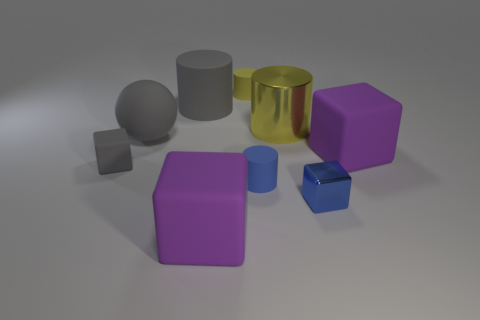What size is the matte sphere that is the same color as the big matte cylinder?
Keep it short and to the point. Large. There is a cylinder that is the same color as the tiny metal thing; what is its material?
Make the answer very short. Rubber. Is there a gray cube that has the same size as the ball?
Your response must be concise. No. Are there the same number of small cubes that are right of the large metal object and small gray blocks right of the big gray sphere?
Provide a succinct answer. No. Are there more big gray cylinders than metallic objects?
Your response must be concise. No. How many matte objects are tiny red cylinders or cylinders?
Ensure brevity in your answer.  3. What number of shiny blocks are the same color as the large metallic object?
Keep it short and to the point. 0. There is a big cube in front of the gray thing in front of the big cube that is on the right side of the blue cylinder; what is it made of?
Your answer should be very brief. Rubber. What is the color of the tiny block to the left of the big rubber thing that is left of the gray cylinder?
Your answer should be very brief. Gray. How many large objects are gray rubber balls or rubber cubes?
Make the answer very short. 3. 